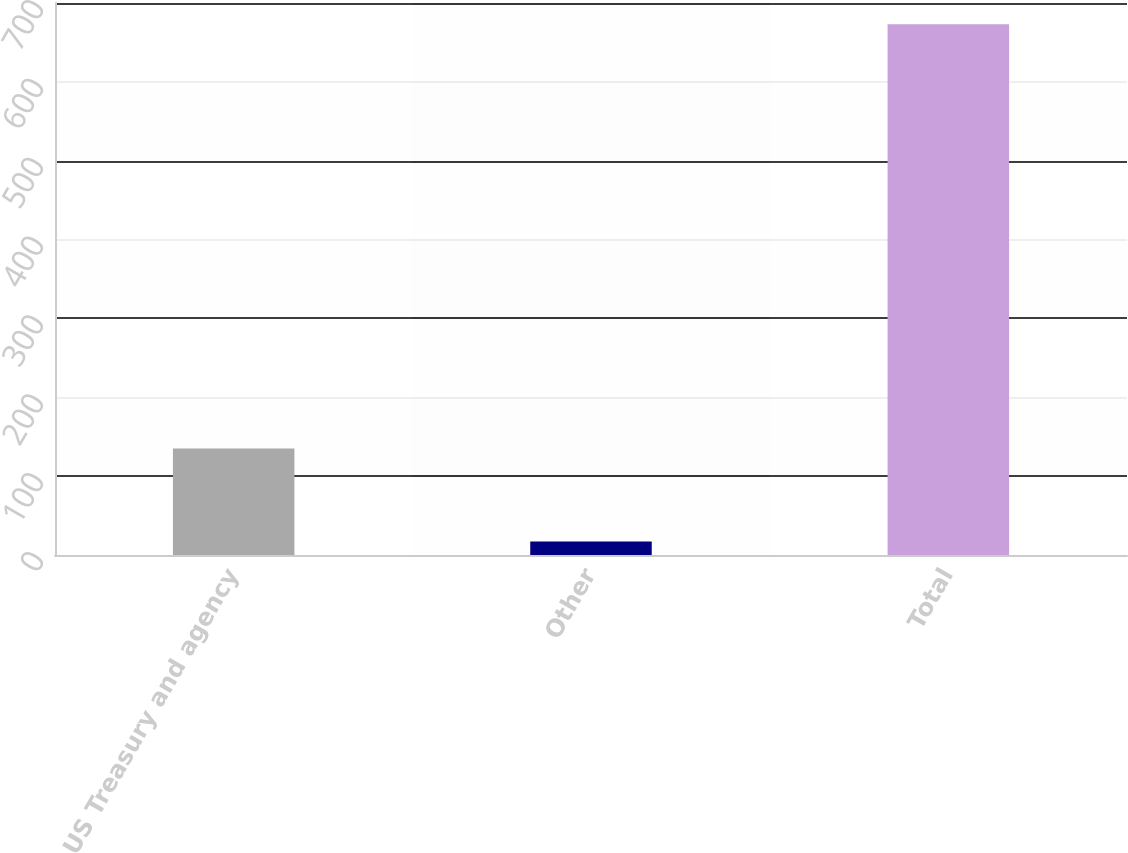Convert chart to OTSL. <chart><loc_0><loc_0><loc_500><loc_500><bar_chart><fcel>US Treasury and agency<fcel>Other<fcel>Total<nl><fcel>135<fcel>17<fcel>673<nl></chart> 